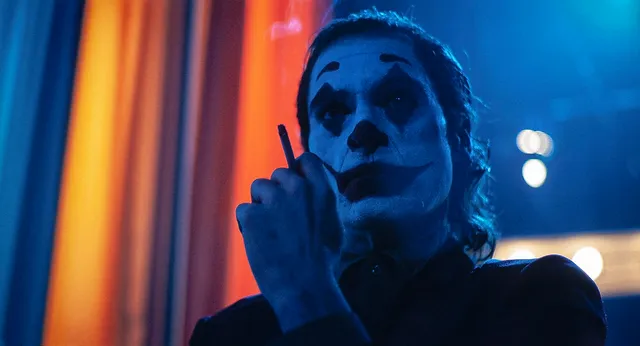Can you describe the emotions conveyed in this image? The image vividly conveys a complex array of emotions. Joaquin Phoenix, as the Joker, exudes an aura of intense reflection mixed with inner turmoil. His serious, almost contemplative expression, paired with the act of holding a cigarette, suggests a moment of deep thought or plotting. The stark contrast of the theatrical makeup against his skin highlights the duality of his character's chaotic inner world. The overall mood is haunting and introspective, encapsulating a sense of foreboding intensity. What might be going through the Joker’s mind in this moment? In this moment, the Joker might be contemplating the chaos he is about to unleash. Given his contemplative demeanor and the intensity of his gaze, he could be reflecting on his past, the injustices he perceives, and the plans he has for the future. The cigarette suggests a moment of pause, perhaps indicating a personal ritual before embarking on a significant action. This moment captures his strategic mindset, underscored by a simmering rage and a desire for retribution that fuels his anarchic ambitions. 